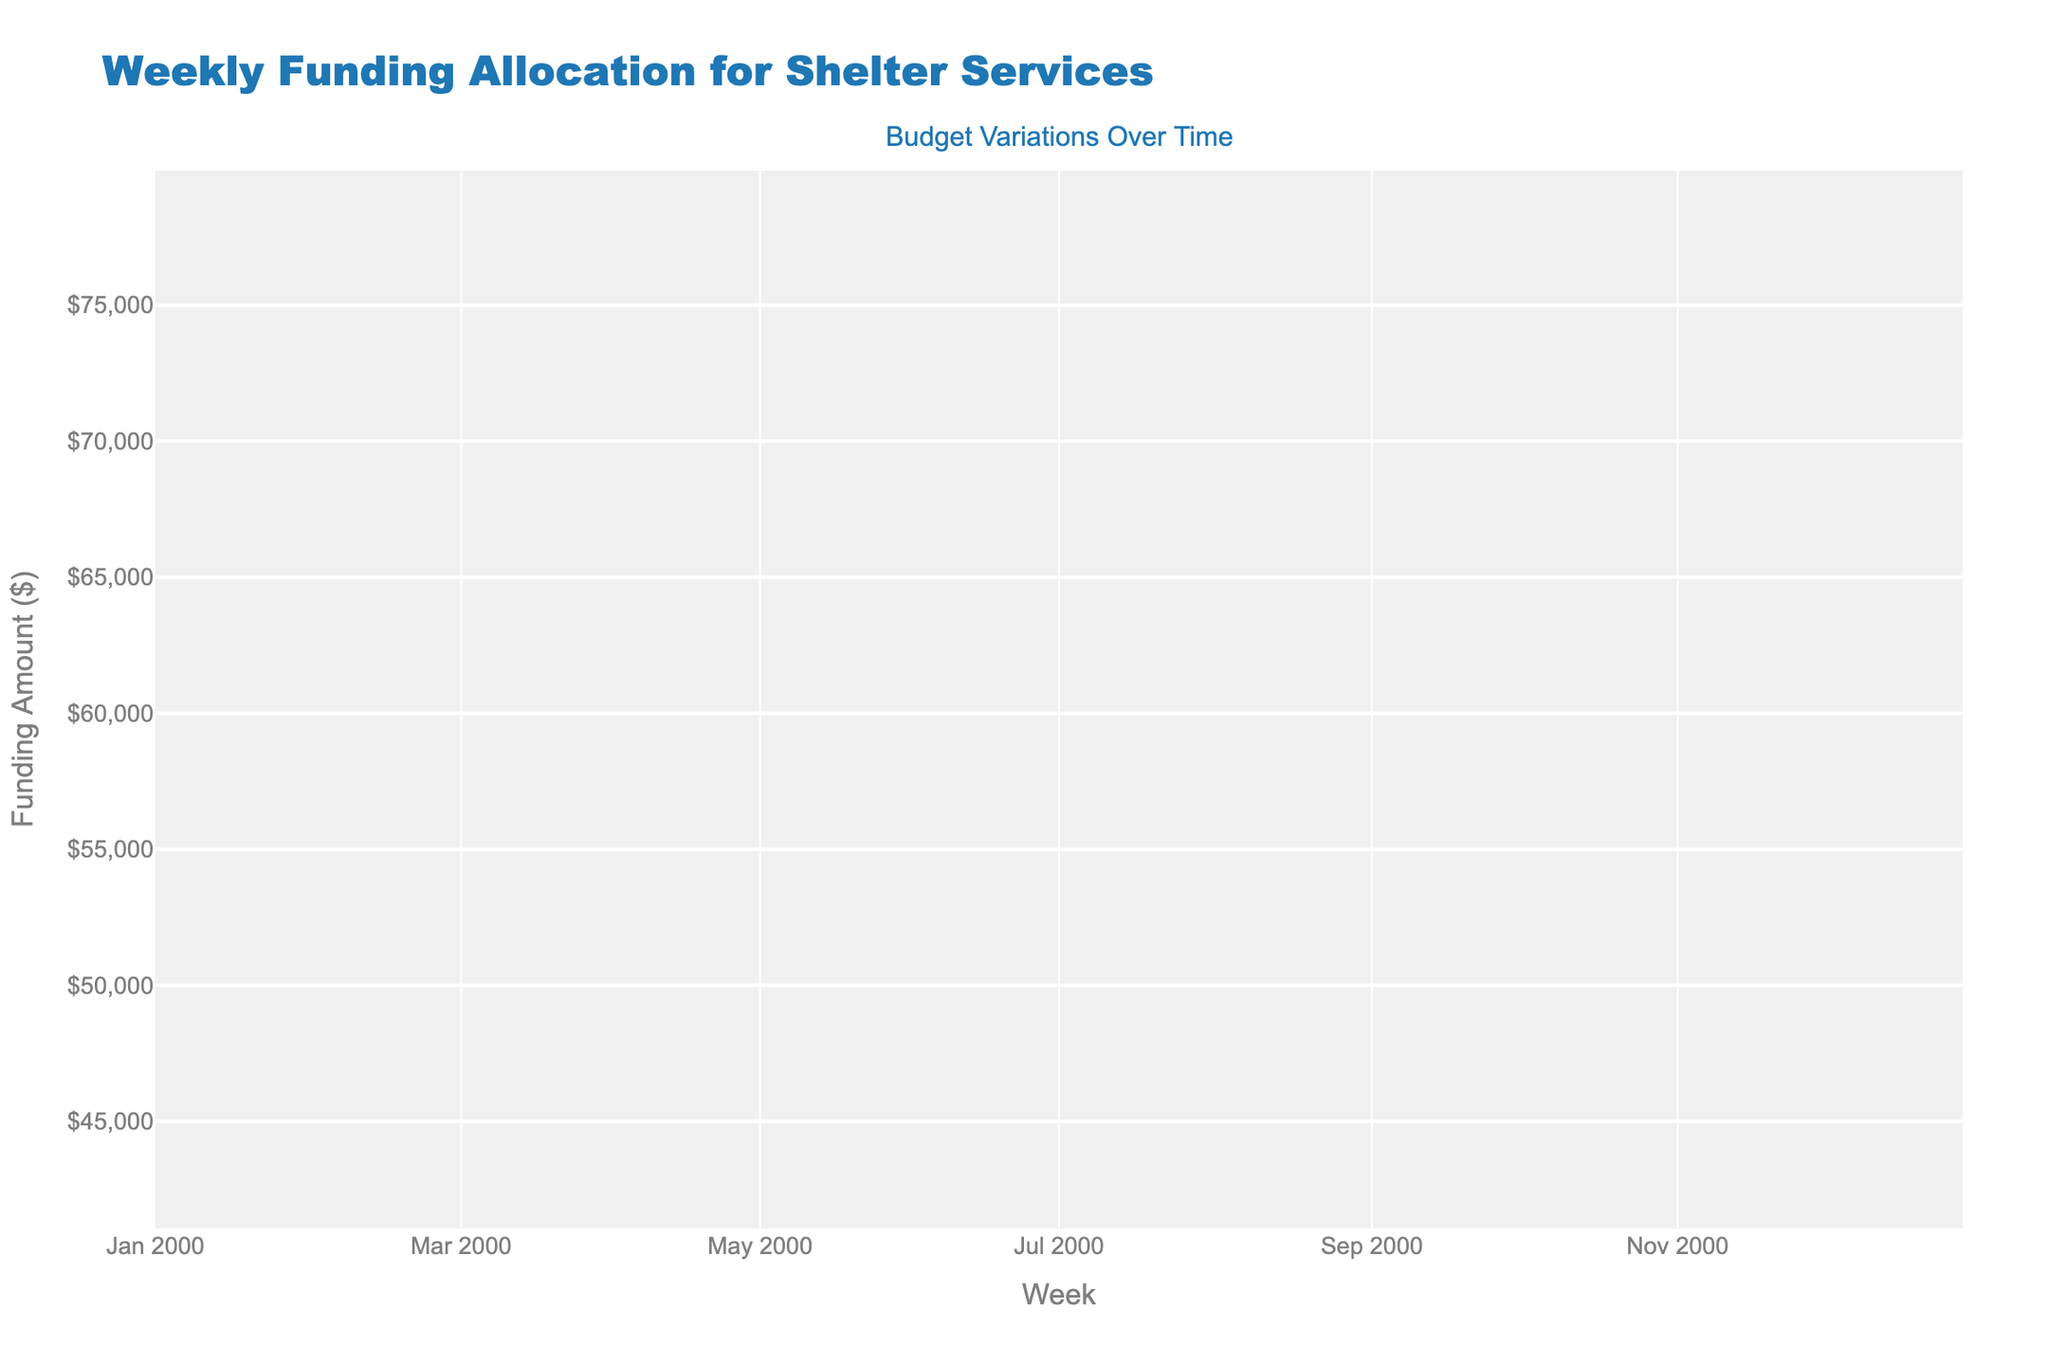What is the title of the figure? The title of the figure can be found at the top, indicating the subject of the chart.
Answer: Weekly Funding Allocation for Shelter Services What are the dates of the first and last data points shown in the chart? The dates of the first and last data points can be inferred from the x-axis labels, which show the weekly periods. The first data point is from Jan 1-7, and the last data point is from Mar 19-25.
Answer: Jan 1-7 to Mar 19-25 What is the maximum funding amount shown on the y-axis? To find the maximum funding amount, look at the highest value on the y-axis. The highest value shown is $80,000.
Answer: $80,000 Which week had the highest closing funding amount? To determine this, look at the closing prices of each candlestick to find the highest value. The week of Mar 19-25 had the highest closing funding amount of $74,000.
Answer: Mar 19-25 How much did the funding increase from the first week (Jan 1-7) to the last week (Mar 19-25)? Calculate the difference between the closing funding amounts of the first and last weeks. The funding amount increased from $48,000 to $74,000, so the increase is $74,000 - $48,000 = $26,000.
Answer: $26,000 What is the average closing funding amount over the 12-week period? Sum the closing amounts of all weeks and divide by the number of weeks. The sum is $48,000 + $51,000 + $53,000 + $57,000 + $59,000 + $62,000 + $64,000 + $66,000 + $68,000 + $70,000 + $72,000 + $74,000 = $744,000. The average is $744,000 / 12 = $62,000.
Answer: $62,000 Which week experienced the maximum range in funding amounts (difference between high and low)? Calculate the range for each week by subtracting the low value from the high value. Identify the week with the highest range. The week of Mar 19-25 had the highest range: $78,000 - $69,000 = $9,000.
Answer: Mar 19-25 How did the funding amount change during the week of Feb 5-11? Observe the candlestick for Feb 5-11. The funding opened at $59,000 and closed at $62,000, with a low of $56,000 and a high of $65,000. Hence, the funding increased from $59,000 to $62,000.
Answer: Increased from $59,000 to $62,000 What was the general trend in funding amounts over the 12 weeks? Examine the overall direction of the candlesticks from start to end. The chart generally shows an upward trend, indicated by increasing closing values over time.
Answer: Upward trend Which week had the smallest difference between the open and close funding amounts? Calculate the difference between the open and close funding amounts for each week, finding the smallest difference. The week of Jan 15-21 had the smallest difference: $53,000 - $51,000 = $2,000.
Answer: Jan 15-21 